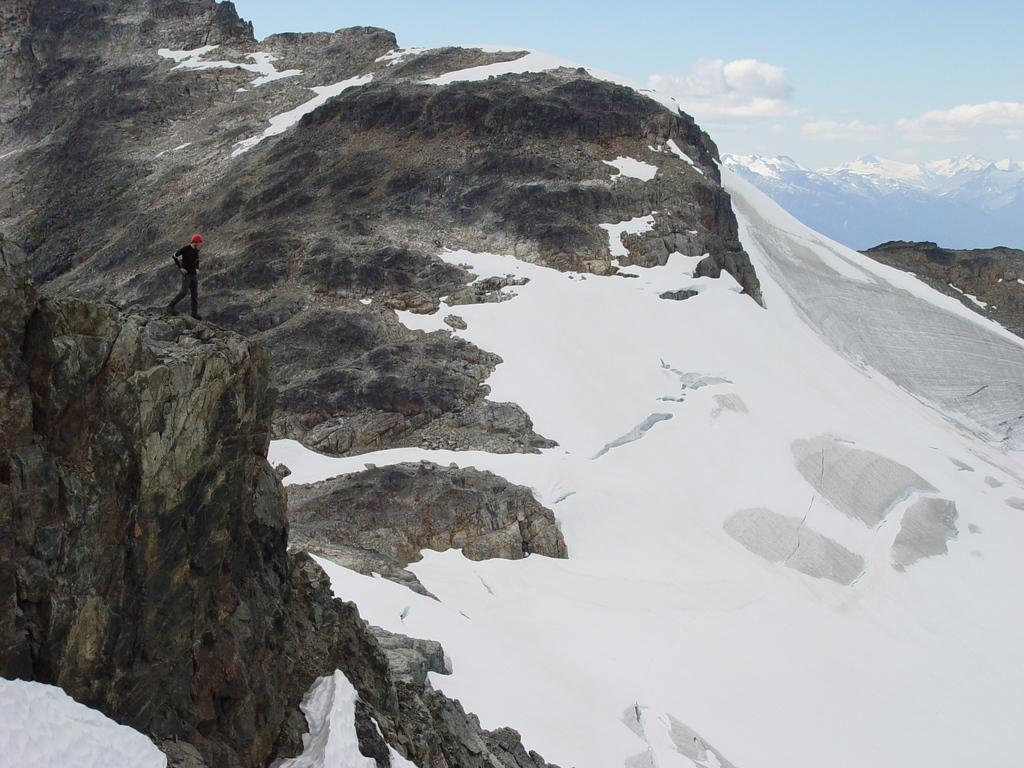What is the main feature in the center of the image? There is snow and a hill in the center of the image. Is there a person in the image? Yes, there is a person standing in the center of the image. What can be seen in the background of the image? The sky and clouds are visible in the background of the image. Where is the jail located in the image? There is no jail present in the image. Can you see a rat in the image? There is no rat present in the image. 